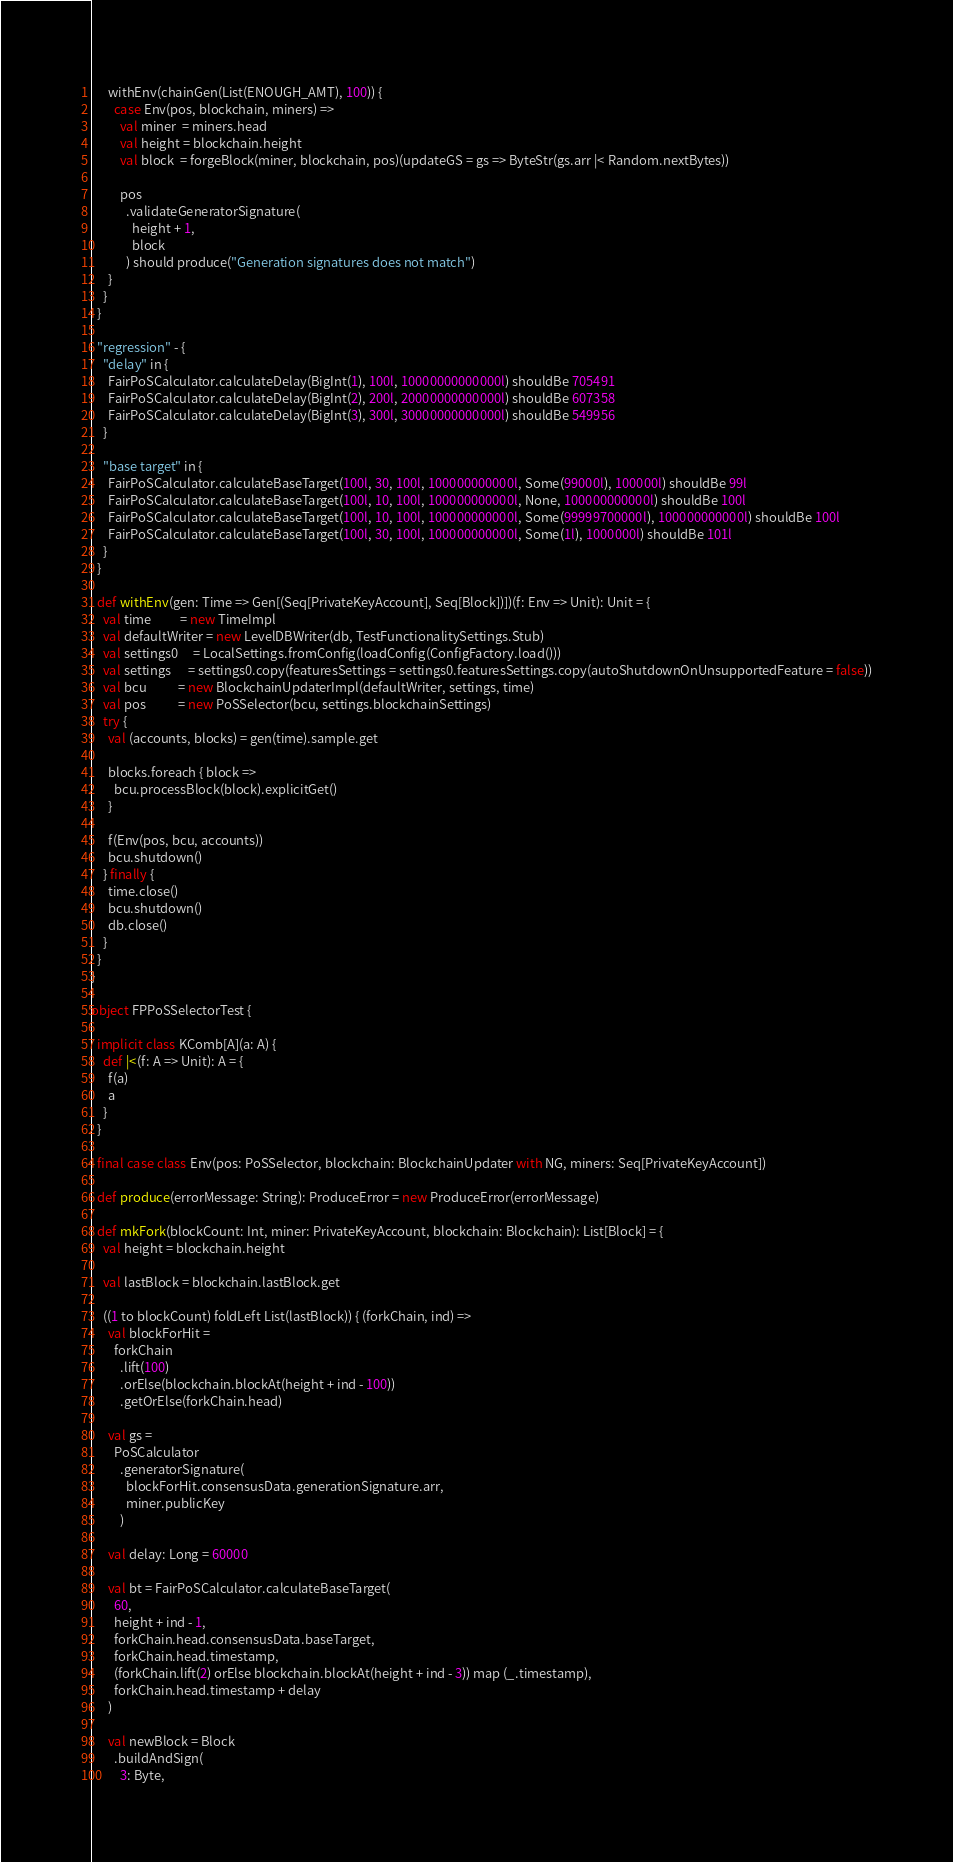<code> <loc_0><loc_0><loc_500><loc_500><_Scala_>      withEnv(chainGen(List(ENOUGH_AMT), 100)) {
        case Env(pos, blockchain, miners) =>
          val miner  = miners.head
          val height = blockchain.height
          val block  = forgeBlock(miner, blockchain, pos)(updateGS = gs => ByteStr(gs.arr |< Random.nextBytes))

          pos
            .validateGeneratorSignature(
              height + 1,
              block
            ) should produce("Generation signatures does not match")
      }
    }
  }

  "regression" - {
    "delay" in {
      FairPoSCalculator.calculateDelay(BigInt(1), 100l, 10000000000000l) shouldBe 705491
      FairPoSCalculator.calculateDelay(BigInt(2), 200l, 20000000000000l) shouldBe 607358
      FairPoSCalculator.calculateDelay(BigInt(3), 300l, 30000000000000l) shouldBe 549956
    }

    "base target" in {
      FairPoSCalculator.calculateBaseTarget(100l, 30, 100l, 100000000000l, Some(99000l), 100000l) shouldBe 99l
      FairPoSCalculator.calculateBaseTarget(100l, 10, 100l, 100000000000l, None, 100000000000l) shouldBe 100l
      FairPoSCalculator.calculateBaseTarget(100l, 10, 100l, 100000000000l, Some(99999700000l), 100000000000l) shouldBe 100l
      FairPoSCalculator.calculateBaseTarget(100l, 30, 100l, 100000000000l, Some(1l), 1000000l) shouldBe 101l
    }
  }

  def withEnv(gen: Time => Gen[(Seq[PrivateKeyAccount], Seq[Block])])(f: Env => Unit): Unit = {
    val time          = new TimeImpl
    val defaultWriter = new LevelDBWriter(db, TestFunctionalitySettings.Stub)
    val settings0     = LocalSettings.fromConfig(loadConfig(ConfigFactory.load()))
    val settings      = settings0.copy(featuresSettings = settings0.featuresSettings.copy(autoShutdownOnUnsupportedFeature = false))
    val bcu           = new BlockchainUpdaterImpl(defaultWriter, settings, time)
    val pos           = new PoSSelector(bcu, settings.blockchainSettings)
    try {
      val (accounts, blocks) = gen(time).sample.get

      blocks.foreach { block =>
        bcu.processBlock(block).explicitGet()
      }

      f(Env(pos, bcu, accounts))
      bcu.shutdown()
    } finally {
      time.close()
      bcu.shutdown()
      db.close()
    }
  }
}

object FPPoSSelectorTest {

  implicit class KComb[A](a: A) {
    def |<(f: A => Unit): A = {
      f(a)
      a
    }
  }

  final case class Env(pos: PoSSelector, blockchain: BlockchainUpdater with NG, miners: Seq[PrivateKeyAccount])

  def produce(errorMessage: String): ProduceError = new ProduceError(errorMessage)

  def mkFork(blockCount: Int, miner: PrivateKeyAccount, blockchain: Blockchain): List[Block] = {
    val height = blockchain.height

    val lastBlock = blockchain.lastBlock.get

    ((1 to blockCount) foldLeft List(lastBlock)) { (forkChain, ind) =>
      val blockForHit =
        forkChain
          .lift(100)
          .orElse(blockchain.blockAt(height + ind - 100))
          .getOrElse(forkChain.head)

      val gs =
        PoSCalculator
          .generatorSignature(
            blockForHit.consensusData.generationSignature.arr,
            miner.publicKey
          )

      val delay: Long = 60000

      val bt = FairPoSCalculator.calculateBaseTarget(
        60,
        height + ind - 1,
        forkChain.head.consensusData.baseTarget,
        forkChain.head.timestamp,
        (forkChain.lift(2) orElse blockchain.blockAt(height + ind - 3)) map (_.timestamp),
        forkChain.head.timestamp + delay
      )

      val newBlock = Block
        .buildAndSign(
          3: Byte,</code> 